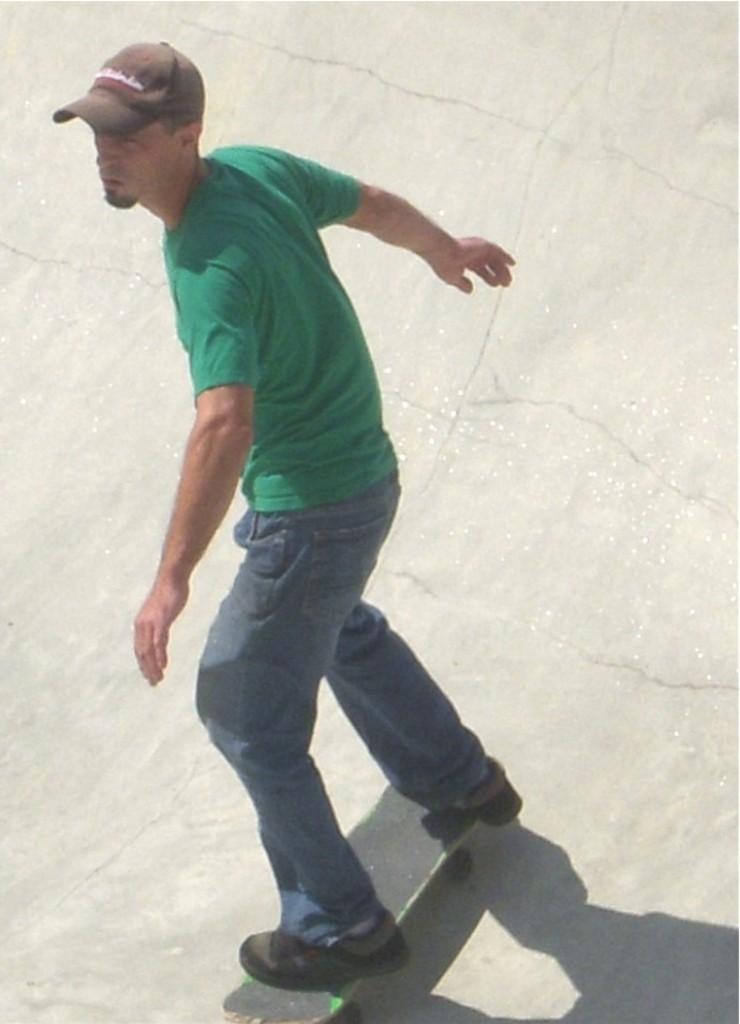What is the person in the image doing? The person in the image is skating. What can be observed about the person's clothing in the image? The person is wearing a green color T-shirt. What type of headwear is the person wearing in the image? The person is wearing a cap. What type of trouble is the person in the image facing? There is no indication in the image that the person is facing any trouble. Can you tell me how many family members are present in the image? There is no reference to family members in the image; only one person is visible. 